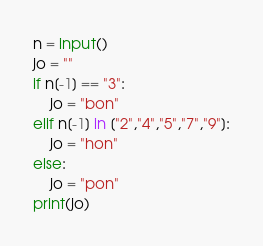<code> <loc_0><loc_0><loc_500><loc_500><_Python_>n = input()
jo = ""
if n[-1] == "3":
    jo = "bon"
elif n[-1] in ["2","4","5","7","9"]:
    jo = "hon"
else:
    jo = "pon"
print(jo)</code> 